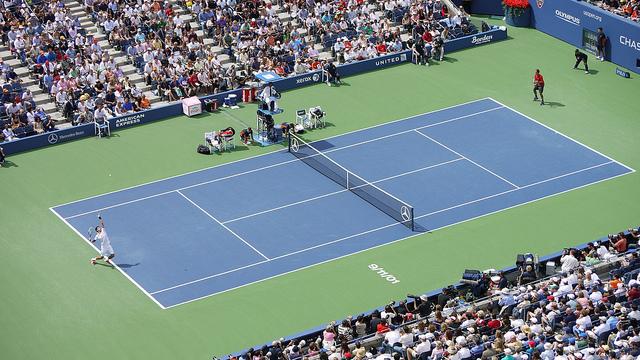What is the name of one of the event sponsors?
Quick response, please. Chase. Is this picture taken from a good seat?
Short answer required. No. Is the referee standing at a good vantage point?
Keep it brief. Yes. 